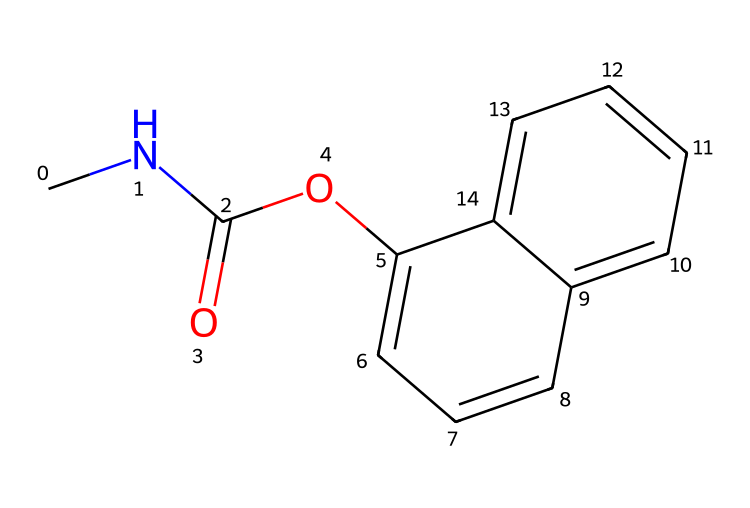What is the molecular formula of carbaryl? To find the molecular formula, we need to count the number of each type of atom in the chemical structure. By analyzing the SMILES, we identify 12 carbon (C) atoms, 15 hydrogen (H) atoms, 1 nitrogen (N) atom, and 2 oxygen (O) atoms, which gives us the formula C12H15NO2.
Answer: C12H15NO2 How many rings are present in the structure? Looking at the chemical structure, we can observe that there are two fused aromatic rings in the backbone of carbaryl. These are indicated by the 'c' (aromatic carbon) in the SMILES representation.
Answer: 2 What functional groups are present in carbaryl? The functional groups can be identified by examining the structure. Carbaryl contains an amide group (due to the presence of nitrogen bonded to a carbonyl) and an ether group (due to the oxygen connected to carbon). This gives us an amide and an ether as its functional groups.
Answer: amide, ether How many double bonds are in carbaryl? To find the number of double bonds, we examine the structure for the "=O" notation and other carbon-carbon double bonds suggested by the aromatic rings. There are two double bonds: one in the carbamide (C=O) and multiple due to the aromatic rings, resulting in a total of 5 if we count the bonding in the rings.
Answer: 5 Is carbaryl classified as a carbamate? Carbaryl is derived from the carbamate family of pesticides which typically contain a carbamate functional group and such derivatives like carbaryl confirm this classification. Hence, it is indeed classified as a carbamate.
Answer: Yes What is the role of the nitrogen atom in carbaryl? The nitrogen atom in carbaryl is part of the amide group, which is crucial for its insecticidal activity. Nitrogen imparts a characteristic structure to the molecule that interacts with pest target systems.
Answer: Insecticidal activity 